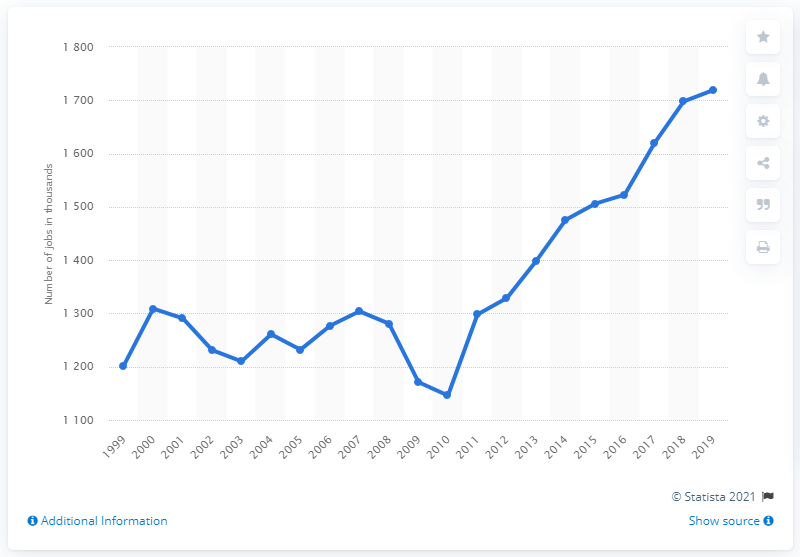Outline some significant characteristics in this image. The direct contribution of the travel and tourism industry to Italy's employment increased in 2010. 